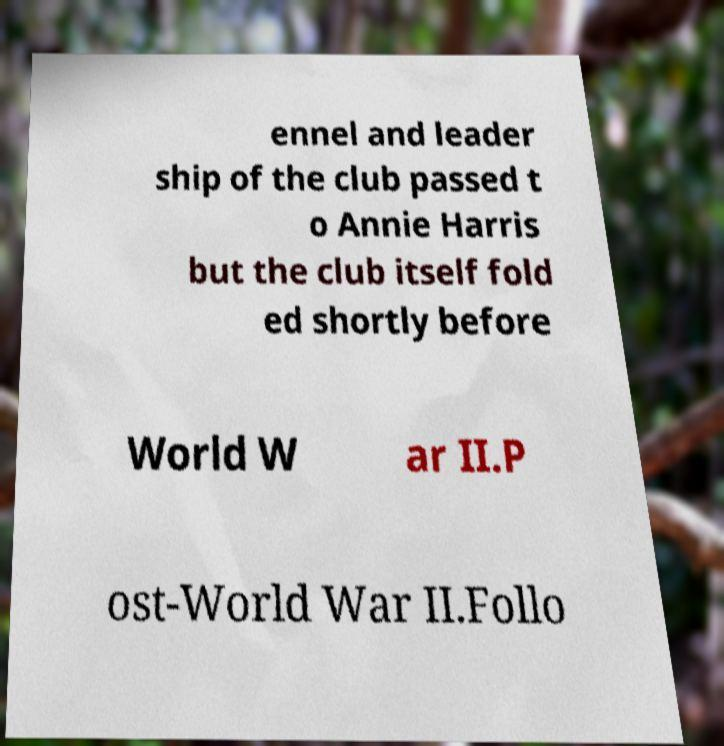Can you read and provide the text displayed in the image?This photo seems to have some interesting text. Can you extract and type it out for me? ennel and leader ship of the club passed t o Annie Harris but the club itself fold ed shortly before World W ar II.P ost-World War II.Follo 